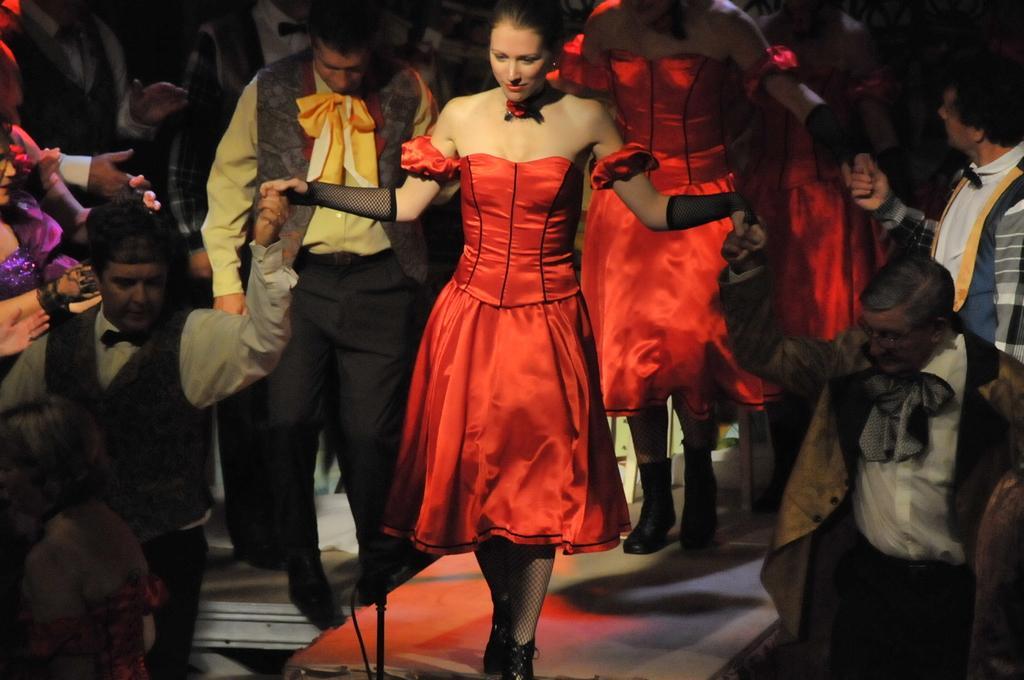Please provide a concise description of this image. In this picture there are few women wearing red dress are standing and there are two men standing and holding the hands of women on either sides of them and there are few other persons in the background. 